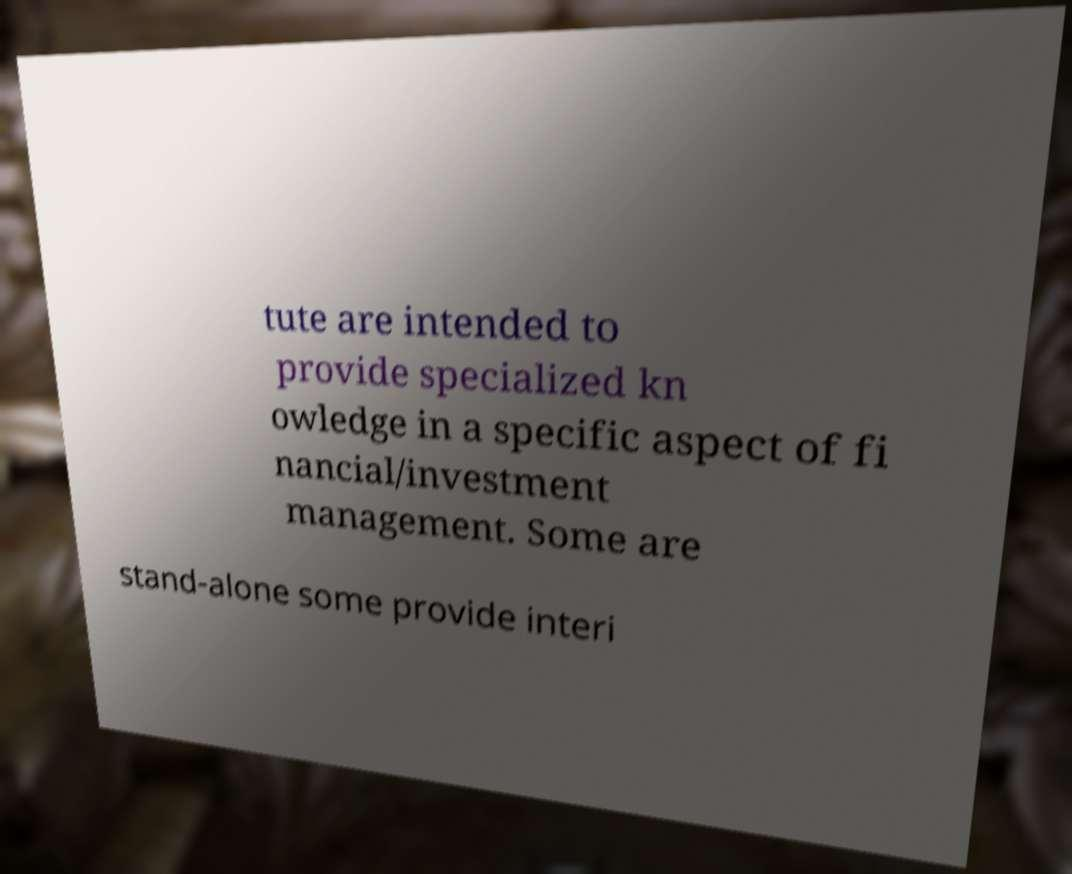Could you assist in decoding the text presented in this image and type it out clearly? tute are intended to provide specialized kn owledge in a specific aspect of fi nancial/investment management. Some are stand-alone some provide interi 